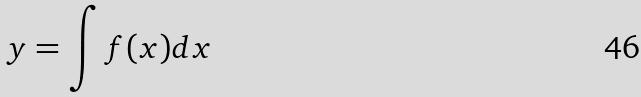Convert formula to latex. <formula><loc_0><loc_0><loc_500><loc_500>y = \int f ( x ) d x</formula> 